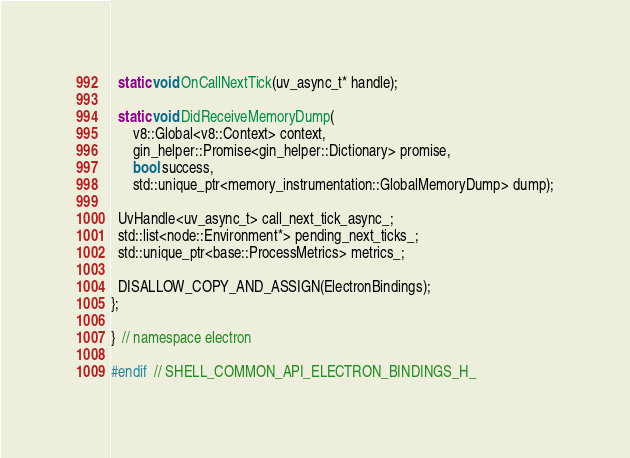<code> <loc_0><loc_0><loc_500><loc_500><_C_>
  static void OnCallNextTick(uv_async_t* handle);

  static void DidReceiveMemoryDump(
      v8::Global<v8::Context> context,
      gin_helper::Promise<gin_helper::Dictionary> promise,
      bool success,
      std::unique_ptr<memory_instrumentation::GlobalMemoryDump> dump);

  UvHandle<uv_async_t> call_next_tick_async_;
  std::list<node::Environment*> pending_next_ticks_;
  std::unique_ptr<base::ProcessMetrics> metrics_;

  DISALLOW_COPY_AND_ASSIGN(ElectronBindings);
};

}  // namespace electron

#endif  // SHELL_COMMON_API_ELECTRON_BINDINGS_H_
</code> 